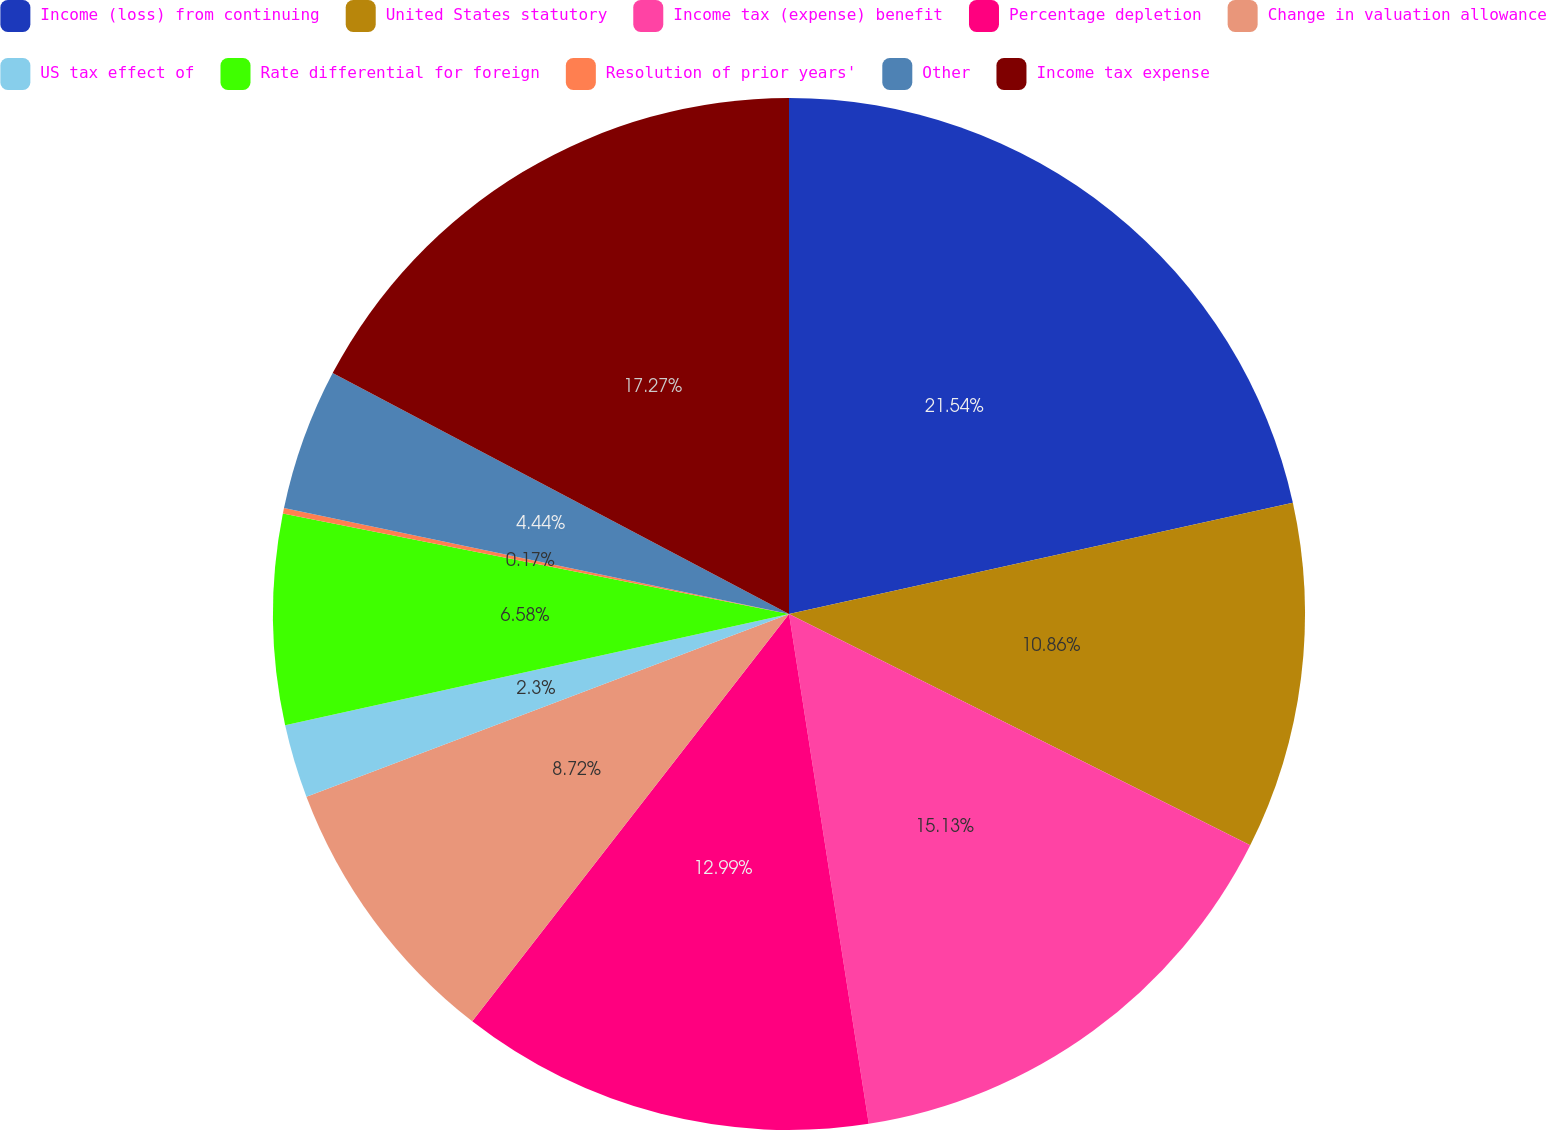Convert chart. <chart><loc_0><loc_0><loc_500><loc_500><pie_chart><fcel>Income (loss) from continuing<fcel>United States statutory<fcel>Income tax (expense) benefit<fcel>Percentage depletion<fcel>Change in valuation allowance<fcel>US tax effect of<fcel>Rate differential for foreign<fcel>Resolution of prior years'<fcel>Other<fcel>Income tax expense<nl><fcel>21.54%<fcel>10.86%<fcel>15.13%<fcel>12.99%<fcel>8.72%<fcel>2.3%<fcel>6.58%<fcel>0.17%<fcel>4.44%<fcel>17.27%<nl></chart> 